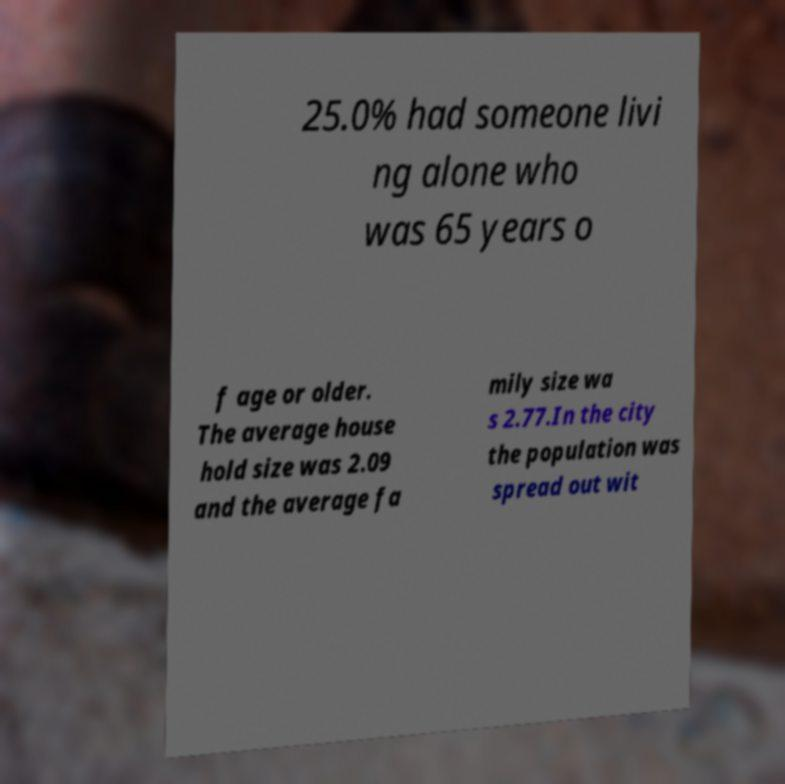Can you read and provide the text displayed in the image?This photo seems to have some interesting text. Can you extract and type it out for me? 25.0% had someone livi ng alone who was 65 years o f age or older. The average house hold size was 2.09 and the average fa mily size wa s 2.77.In the city the population was spread out wit 